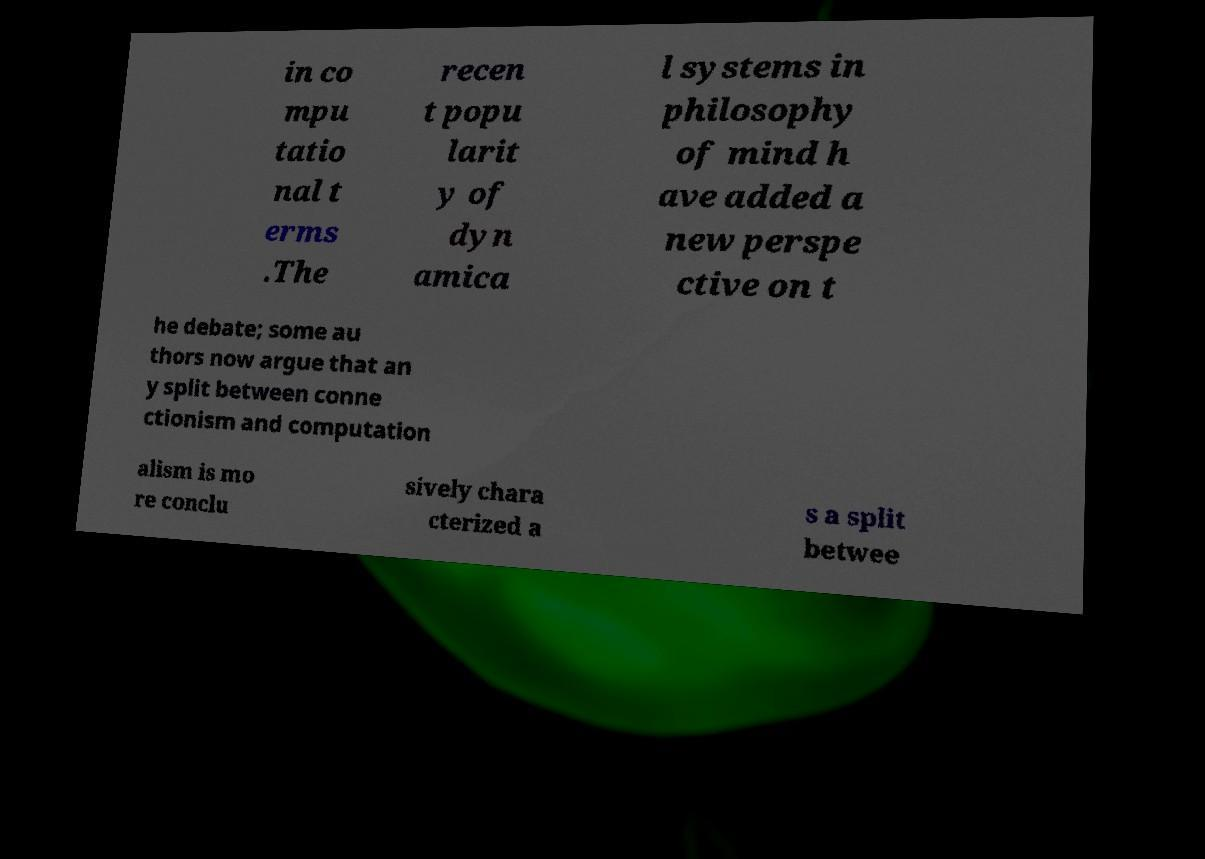There's text embedded in this image that I need extracted. Can you transcribe it verbatim? in co mpu tatio nal t erms .The recen t popu larit y of dyn amica l systems in philosophy of mind h ave added a new perspe ctive on t he debate; some au thors now argue that an y split between conne ctionism and computation alism is mo re conclu sively chara cterized a s a split betwee 